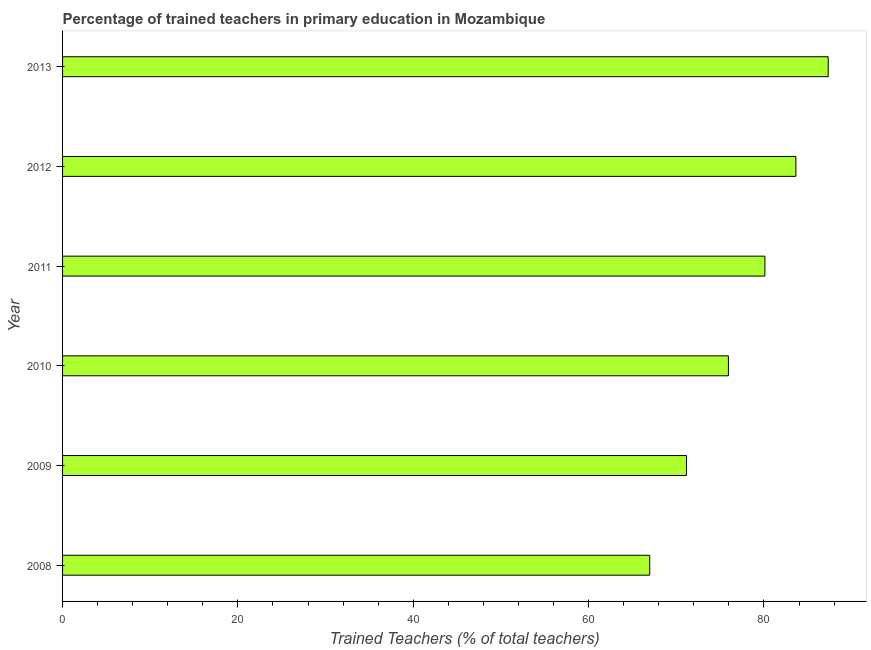Does the graph contain any zero values?
Offer a terse response. No. Does the graph contain grids?
Your answer should be very brief. No. What is the title of the graph?
Provide a short and direct response. Percentage of trained teachers in primary education in Mozambique. What is the label or title of the X-axis?
Provide a succinct answer. Trained Teachers (% of total teachers). What is the percentage of trained teachers in 2009?
Offer a terse response. 71.16. Across all years, what is the maximum percentage of trained teachers?
Offer a terse response. 87.33. Across all years, what is the minimum percentage of trained teachers?
Your answer should be compact. 66.97. In which year was the percentage of trained teachers maximum?
Ensure brevity in your answer.  2013. What is the sum of the percentage of trained teachers?
Your response must be concise. 465.14. What is the difference between the percentage of trained teachers in 2010 and 2013?
Your answer should be compact. -11.38. What is the average percentage of trained teachers per year?
Keep it short and to the point. 77.52. What is the median percentage of trained teachers?
Offer a terse response. 78.02. In how many years, is the percentage of trained teachers greater than 12 %?
Offer a terse response. 6. What is the ratio of the percentage of trained teachers in 2010 to that in 2011?
Offer a terse response. 0.95. Is the percentage of trained teachers in 2010 less than that in 2011?
Make the answer very short. Yes. What is the difference between the highest and the second highest percentage of trained teachers?
Your answer should be very brief. 3.69. Is the sum of the percentage of trained teachers in 2010 and 2012 greater than the maximum percentage of trained teachers across all years?
Your answer should be very brief. Yes. What is the difference between the highest and the lowest percentage of trained teachers?
Offer a very short reply. 20.36. How many bars are there?
Make the answer very short. 6. Are all the bars in the graph horizontal?
Your answer should be very brief. Yes. What is the difference between two consecutive major ticks on the X-axis?
Your response must be concise. 20. Are the values on the major ticks of X-axis written in scientific E-notation?
Provide a short and direct response. No. What is the Trained Teachers (% of total teachers) of 2008?
Provide a succinct answer. 66.97. What is the Trained Teachers (% of total teachers) in 2009?
Your answer should be compact. 71.16. What is the Trained Teachers (% of total teachers) of 2010?
Offer a terse response. 75.94. What is the Trained Teachers (% of total teachers) of 2011?
Your answer should be very brief. 80.1. What is the Trained Teachers (% of total teachers) in 2012?
Offer a very short reply. 83.64. What is the Trained Teachers (% of total teachers) in 2013?
Make the answer very short. 87.33. What is the difference between the Trained Teachers (% of total teachers) in 2008 and 2009?
Offer a very short reply. -4.19. What is the difference between the Trained Teachers (% of total teachers) in 2008 and 2010?
Your answer should be compact. -8.98. What is the difference between the Trained Teachers (% of total teachers) in 2008 and 2011?
Make the answer very short. -13.14. What is the difference between the Trained Teachers (% of total teachers) in 2008 and 2012?
Keep it short and to the point. -16.67. What is the difference between the Trained Teachers (% of total teachers) in 2008 and 2013?
Provide a short and direct response. -20.36. What is the difference between the Trained Teachers (% of total teachers) in 2009 and 2010?
Your answer should be compact. -4.79. What is the difference between the Trained Teachers (% of total teachers) in 2009 and 2011?
Ensure brevity in your answer.  -8.95. What is the difference between the Trained Teachers (% of total teachers) in 2009 and 2012?
Offer a terse response. -12.48. What is the difference between the Trained Teachers (% of total teachers) in 2009 and 2013?
Offer a terse response. -16.17. What is the difference between the Trained Teachers (% of total teachers) in 2010 and 2011?
Offer a very short reply. -4.16. What is the difference between the Trained Teachers (% of total teachers) in 2010 and 2012?
Provide a short and direct response. -7.7. What is the difference between the Trained Teachers (% of total teachers) in 2010 and 2013?
Your response must be concise. -11.38. What is the difference between the Trained Teachers (% of total teachers) in 2011 and 2012?
Make the answer very short. -3.54. What is the difference between the Trained Teachers (% of total teachers) in 2011 and 2013?
Your answer should be very brief. -7.22. What is the difference between the Trained Teachers (% of total teachers) in 2012 and 2013?
Offer a terse response. -3.69. What is the ratio of the Trained Teachers (% of total teachers) in 2008 to that in 2009?
Your response must be concise. 0.94. What is the ratio of the Trained Teachers (% of total teachers) in 2008 to that in 2010?
Your response must be concise. 0.88. What is the ratio of the Trained Teachers (% of total teachers) in 2008 to that in 2011?
Your response must be concise. 0.84. What is the ratio of the Trained Teachers (% of total teachers) in 2008 to that in 2012?
Give a very brief answer. 0.8. What is the ratio of the Trained Teachers (% of total teachers) in 2008 to that in 2013?
Make the answer very short. 0.77. What is the ratio of the Trained Teachers (% of total teachers) in 2009 to that in 2010?
Provide a short and direct response. 0.94. What is the ratio of the Trained Teachers (% of total teachers) in 2009 to that in 2011?
Offer a very short reply. 0.89. What is the ratio of the Trained Teachers (% of total teachers) in 2009 to that in 2012?
Your answer should be compact. 0.85. What is the ratio of the Trained Teachers (% of total teachers) in 2009 to that in 2013?
Make the answer very short. 0.81. What is the ratio of the Trained Teachers (% of total teachers) in 2010 to that in 2011?
Your response must be concise. 0.95. What is the ratio of the Trained Teachers (% of total teachers) in 2010 to that in 2012?
Give a very brief answer. 0.91. What is the ratio of the Trained Teachers (% of total teachers) in 2010 to that in 2013?
Offer a terse response. 0.87. What is the ratio of the Trained Teachers (% of total teachers) in 2011 to that in 2012?
Offer a very short reply. 0.96. What is the ratio of the Trained Teachers (% of total teachers) in 2011 to that in 2013?
Provide a succinct answer. 0.92. What is the ratio of the Trained Teachers (% of total teachers) in 2012 to that in 2013?
Give a very brief answer. 0.96. 